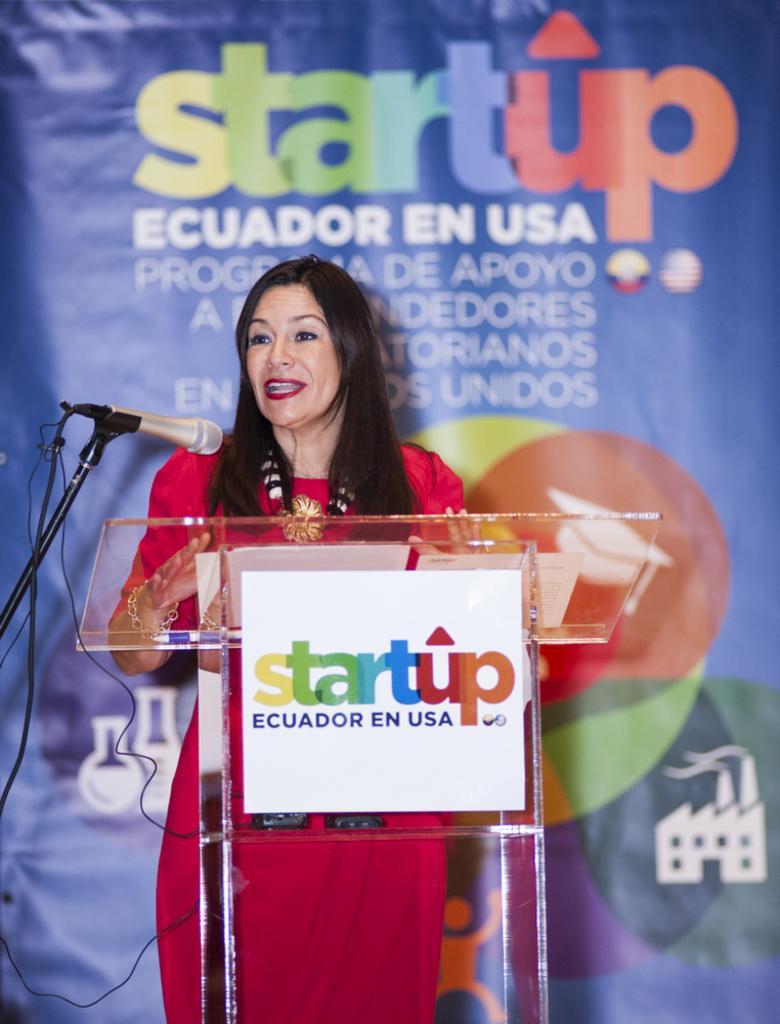In one or two sentences, can you explain what this image depicts? In this image I can see the person standing and the person is wearing red color dress. In front I can see the podium and a microphone. Background the banner is in blue color. 